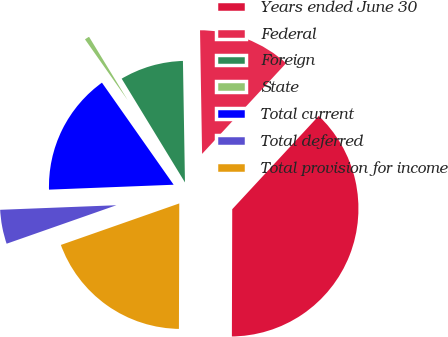<chart> <loc_0><loc_0><loc_500><loc_500><pie_chart><fcel>Years ended June 30<fcel>Federal<fcel>Foreign<fcel>State<fcel>Total current<fcel>Total deferred<fcel>Total provision for income<nl><fcel>38.15%<fcel>12.16%<fcel>8.45%<fcel>1.03%<fcel>15.88%<fcel>4.74%<fcel>19.59%<nl></chart> 